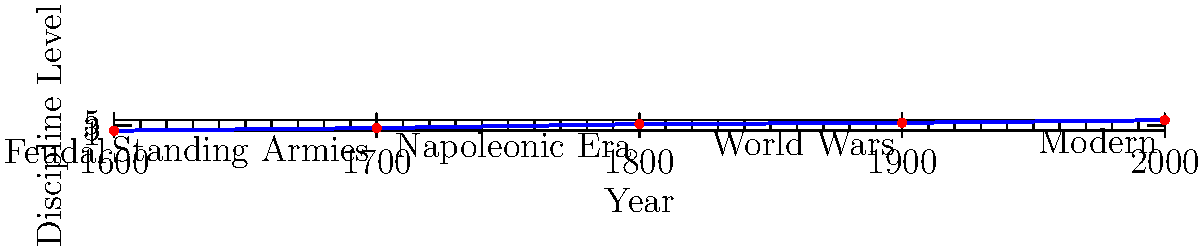Based on the timeline graphic showing the evolution of military discipline from 1600 to 2000, during which period did military discipline experience the most significant increase, and what major historical event or era might have contributed to this change? To answer this question, we need to analyze the graph and identify the steepest increase in the discipline level:

1. From 1600 to 1700: Increase from 1 to 2 (difference of 1)
2. From 1700 to 1800: Increase from 2 to 3.5 (difference of 1.5)
3. From 1800 to 1900: Increase from 3.5 to 4 (difference of 0.5)
4. From 1900 to 2000: Increase from 4 to 5 (difference of 1)

The steepest increase occurred between 1700 and 1800, with a difference of 1.5 points.

This period coincides with the Napoleonic Era, as labeled on the graph. Napoleon Bonaparte's military reforms and the scale of warfare during this time significantly impacted military discipline and organization.

Key factors contributing to this increase in discipline during the Napoleonic Era include:

1. Standardization of military units and tactics
2. Introduction of the corps system
3. Emphasis on meritocracy in officer promotion
4. Improved training and drill techniques
5. The need for better coordination in large-scale battles

These changes laid the foundation for modern military discipline and organization, explaining the significant increase during this period.
Answer: 1700-1800 (Napoleonic Era) 